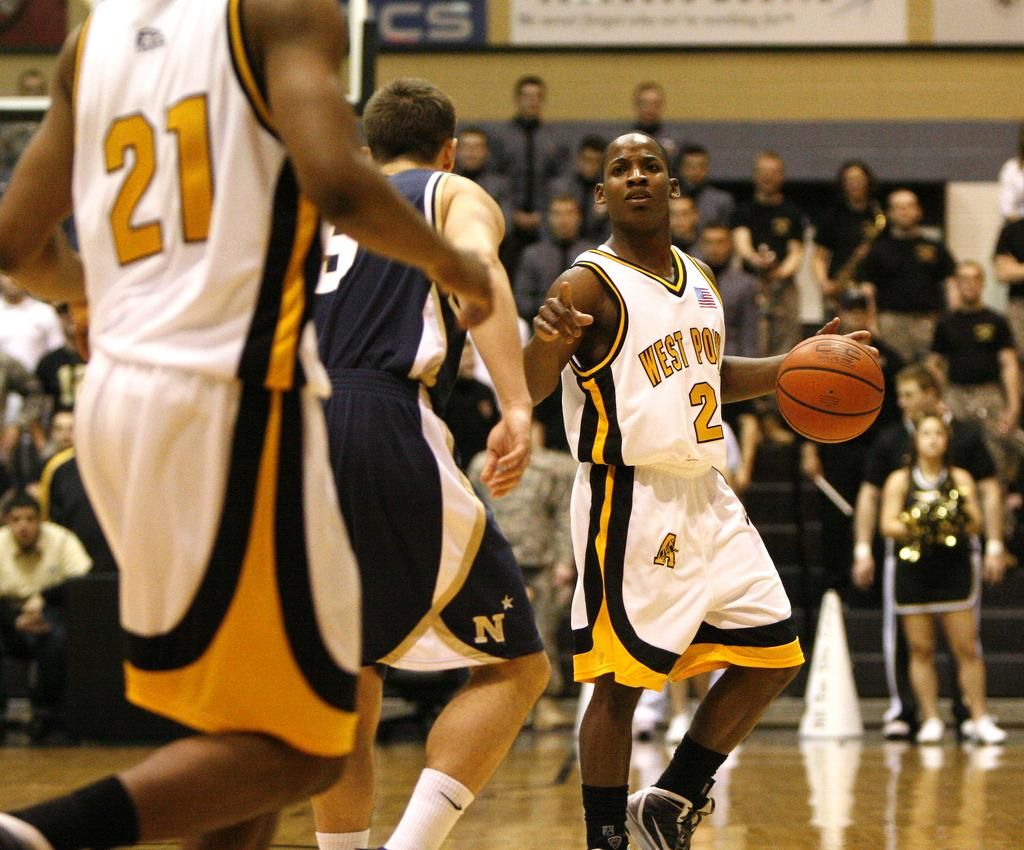<image>
Present a compact description of the photo's key features. A man playing basket \ball wearing a west point jersey. 